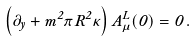<formula> <loc_0><loc_0><loc_500><loc_500>\left ( \partial _ { y } + m ^ { 2 } \pi R ^ { 2 } \kappa \right ) A ^ { L } _ { \mu } ( 0 ) = 0 \, .</formula> 